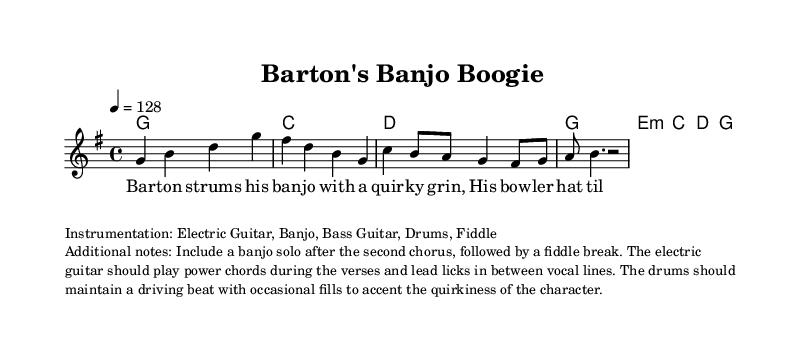What is the key signature of this music? The key signature is G major, which has one sharp (F#). This can be identified in the key signature section at the beginning of the music.
Answer: G major What is the time signature of this music? The time signature is 4/4, indicated at the beginning of the piece with two numbers stacked vertically, where the top number (4) shows beats per measure and the bottom number (4) indicates the note value that receives one beat.
Answer: 4/4 What is the tempo marking for this piece? The tempo marking is 128 beats per minute, shown above the staff with "4 = 128," where "4" represents the quarter note.
Answer: 128 How many measures are there in the melody? There are 8 measures in the melody, counting each separated segment with a bar line. This can be easily counted from the start to the end of the provided melody section.
Answer: 8 What style of instrumentation is used in this piece? The instrumentation includes Electric Guitar, Banjo, Bass Guitar, Drums, and Fiddle, listed in the markup section beneath the score. This section specifies the instruments that should play throughout the piece.
Answer: Electric Guitar, Banjo, Bass Guitar, Drums, Fiddle What unique feature is included after the second chorus? There is a banjo solo included after the second chorus, which is part of the additional notes in the markup section that guides performance and arrangement details.
Answer: Banjo solo What character trait is highlighted in the lyrics of the first verse? The character trait highlighted is "quirky," as indicated in the lyrics where it describes Barton strumming with a "quirky grin." This word conveys the character's unique personality in a playful manner.
Answer: Quirky 